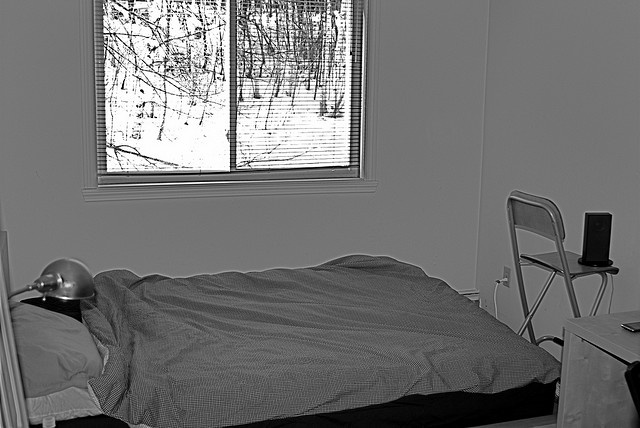Describe the objects in this image and their specific colors. I can see bed in gray and black tones, chair in gray, black, and lightgray tones, and cell phone in gray, black, darkgray, and white tones in this image. 